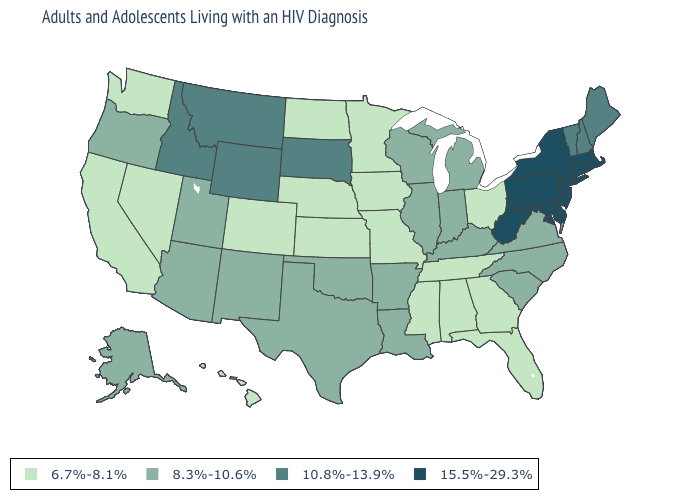What is the value of Arizona?
Give a very brief answer. 8.3%-10.6%. Which states hav the highest value in the MidWest?
Quick response, please. South Dakota. Which states have the highest value in the USA?
Give a very brief answer. Connecticut, Delaware, Maryland, Massachusetts, New Jersey, New York, Pennsylvania, Rhode Island, West Virginia. Does Louisiana have a higher value than Tennessee?
Keep it brief. Yes. Does Washington have the lowest value in the West?
Quick response, please. Yes. What is the value of Hawaii?
Be succinct. 6.7%-8.1%. Does Vermont have the highest value in the Northeast?
Answer briefly. No. Does New Hampshire have the highest value in the Northeast?
Keep it brief. No. Which states hav the highest value in the South?
Quick response, please. Delaware, Maryland, West Virginia. Which states have the lowest value in the Northeast?
Keep it brief. Maine, New Hampshire, Vermont. What is the lowest value in states that border Ohio?
Short answer required. 8.3%-10.6%. Among the states that border Oregon , which have the lowest value?
Give a very brief answer. California, Nevada, Washington. How many symbols are there in the legend?
Concise answer only. 4. Which states hav the highest value in the West?
Concise answer only. Idaho, Montana, Wyoming. 